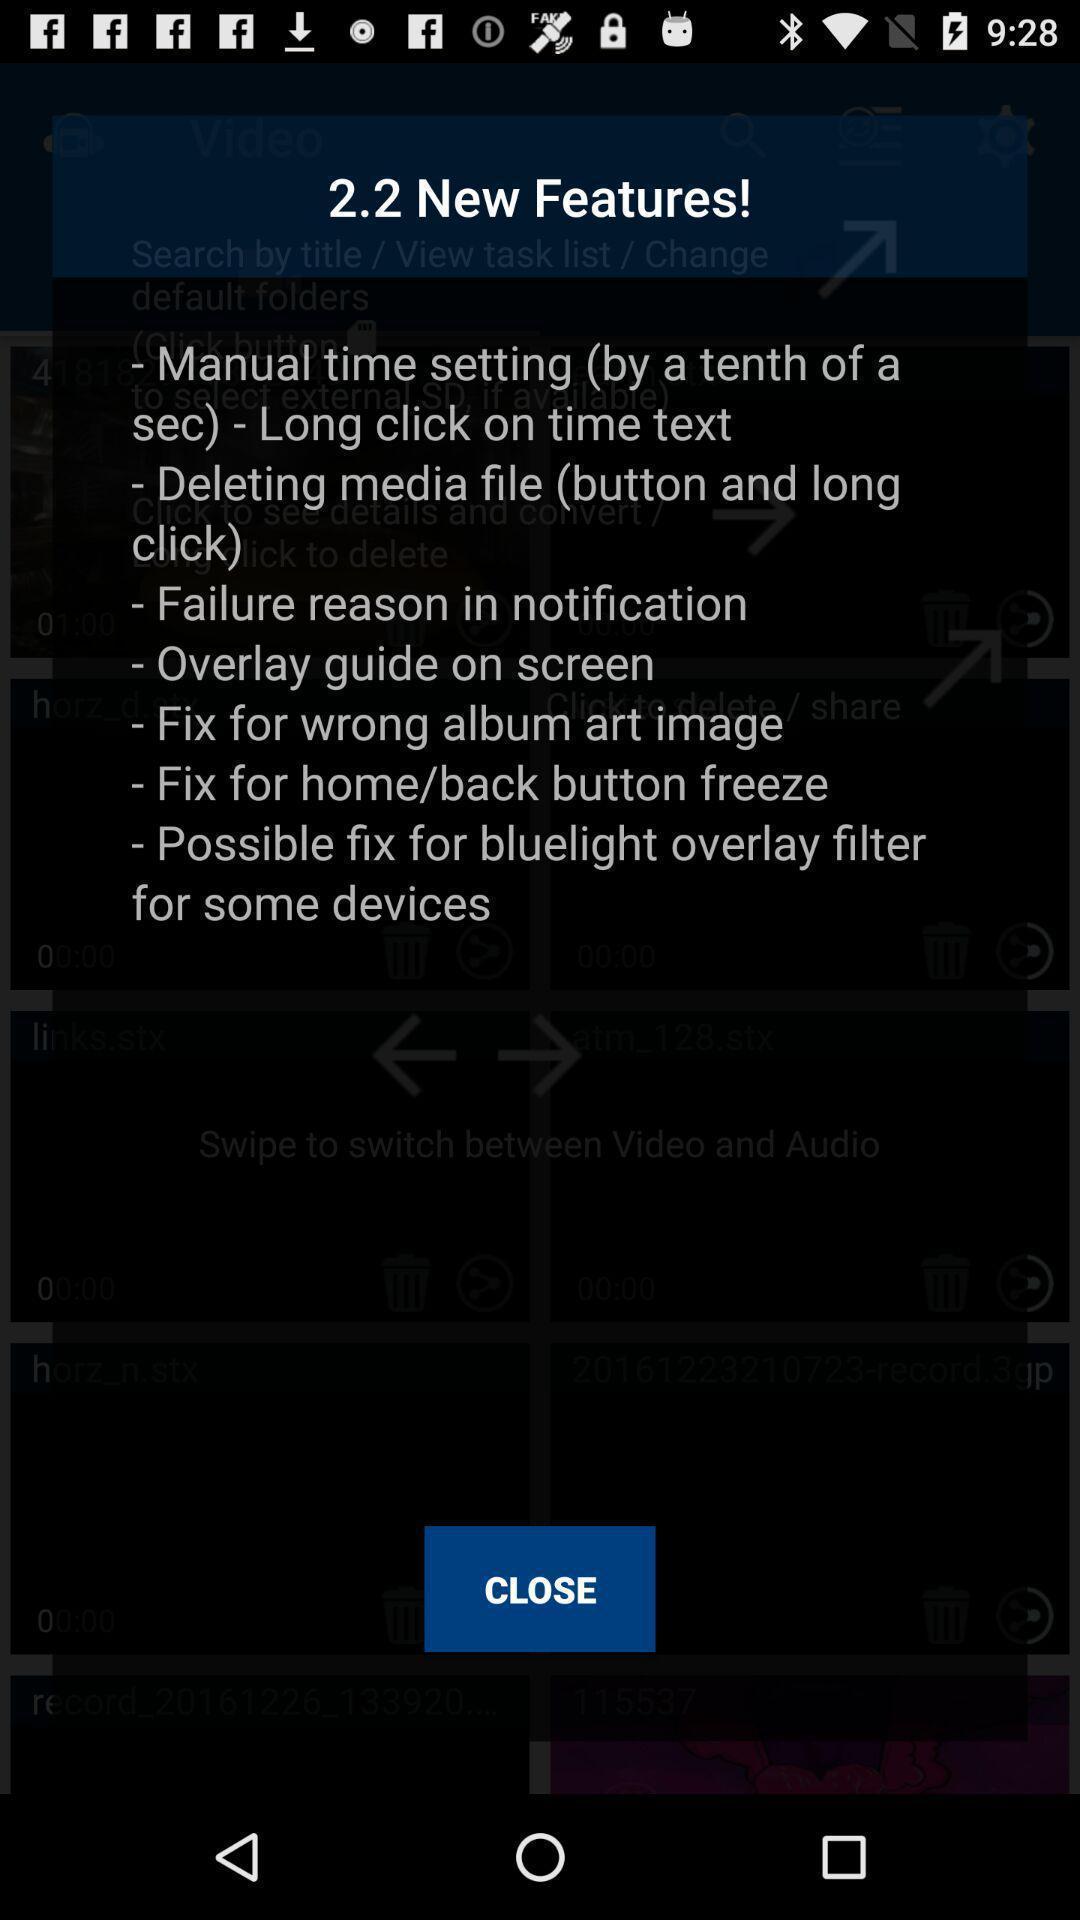Explain the elements present in this screenshot. Screen showing new features. 